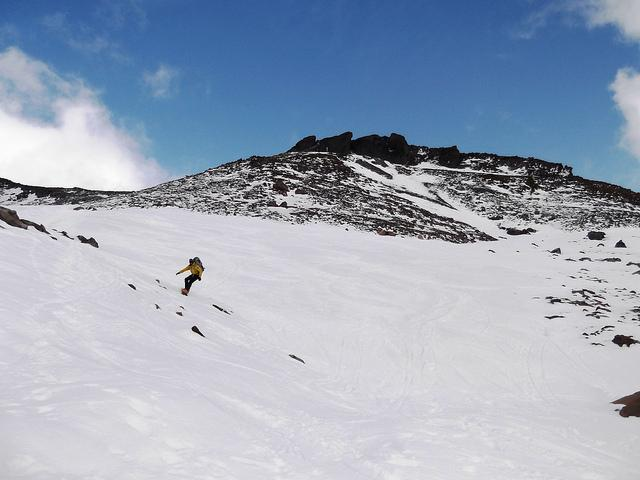What sort of weather happens here frequently? Please explain your reasoning. wind. It is at the top of a mountain which gets strong weather 